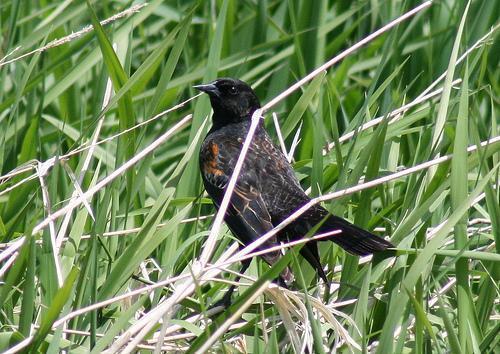How many birds are there?
Give a very brief answer. 1. How many horses are there?
Give a very brief answer. 0. 